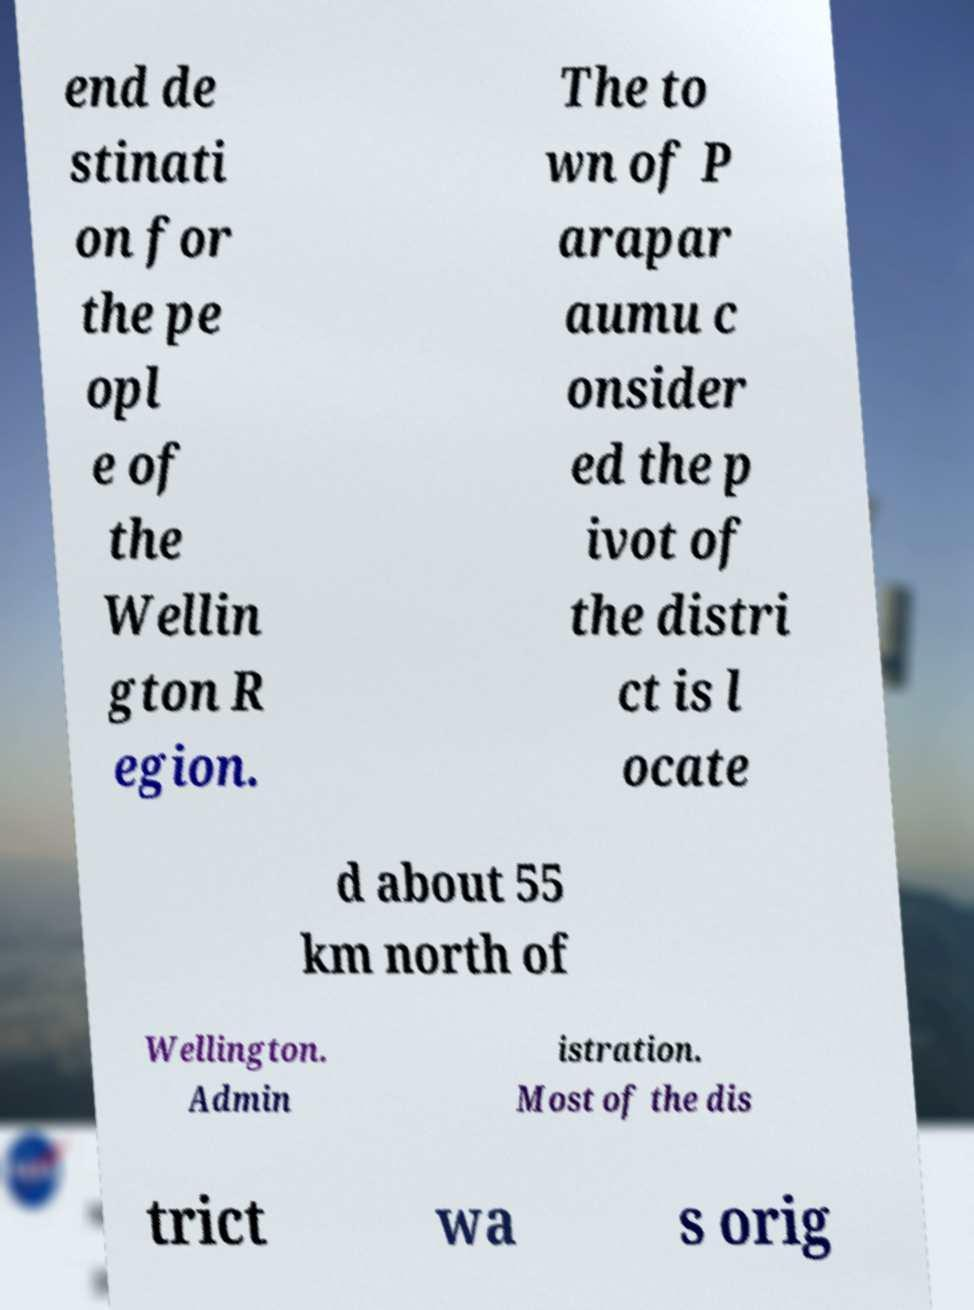Could you extract and type out the text from this image? end de stinati on for the pe opl e of the Wellin gton R egion. The to wn of P arapar aumu c onsider ed the p ivot of the distri ct is l ocate d about 55 km north of Wellington. Admin istration. Most of the dis trict wa s orig 